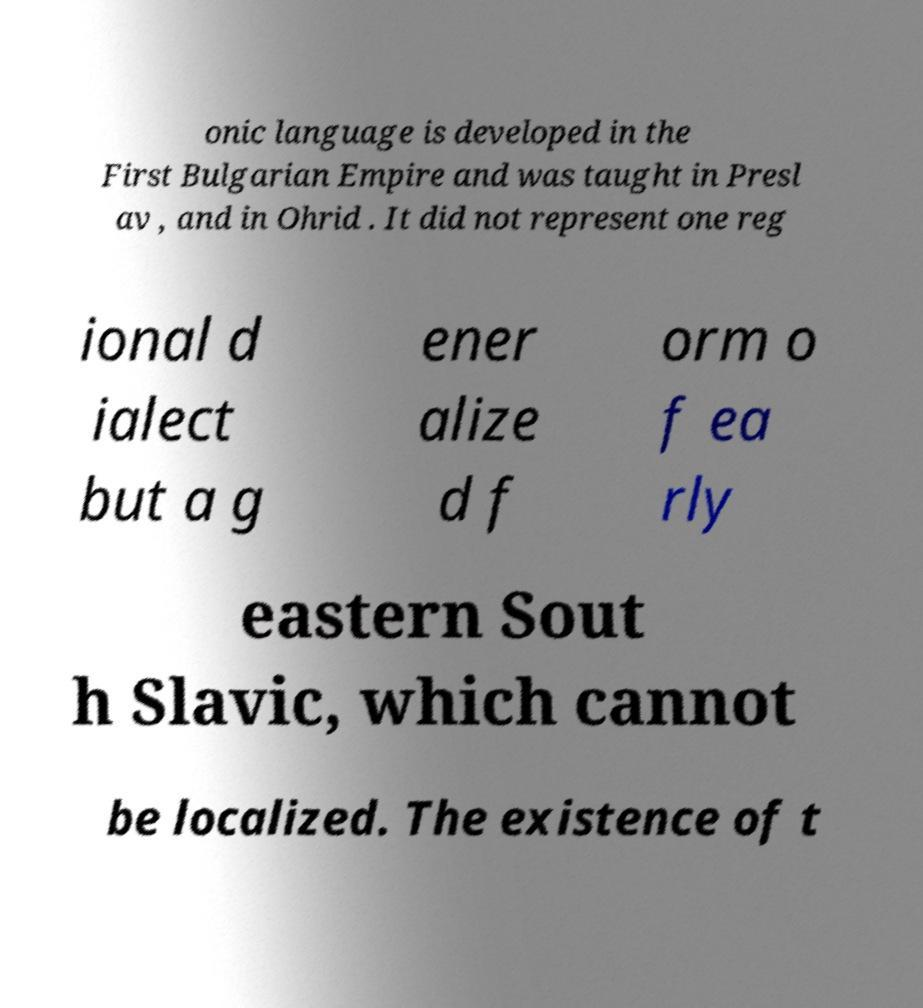Please identify and transcribe the text found in this image. onic language is developed in the First Bulgarian Empire and was taught in Presl av , and in Ohrid . It did not represent one reg ional d ialect but a g ener alize d f orm o f ea rly eastern Sout h Slavic, which cannot be localized. The existence of t 